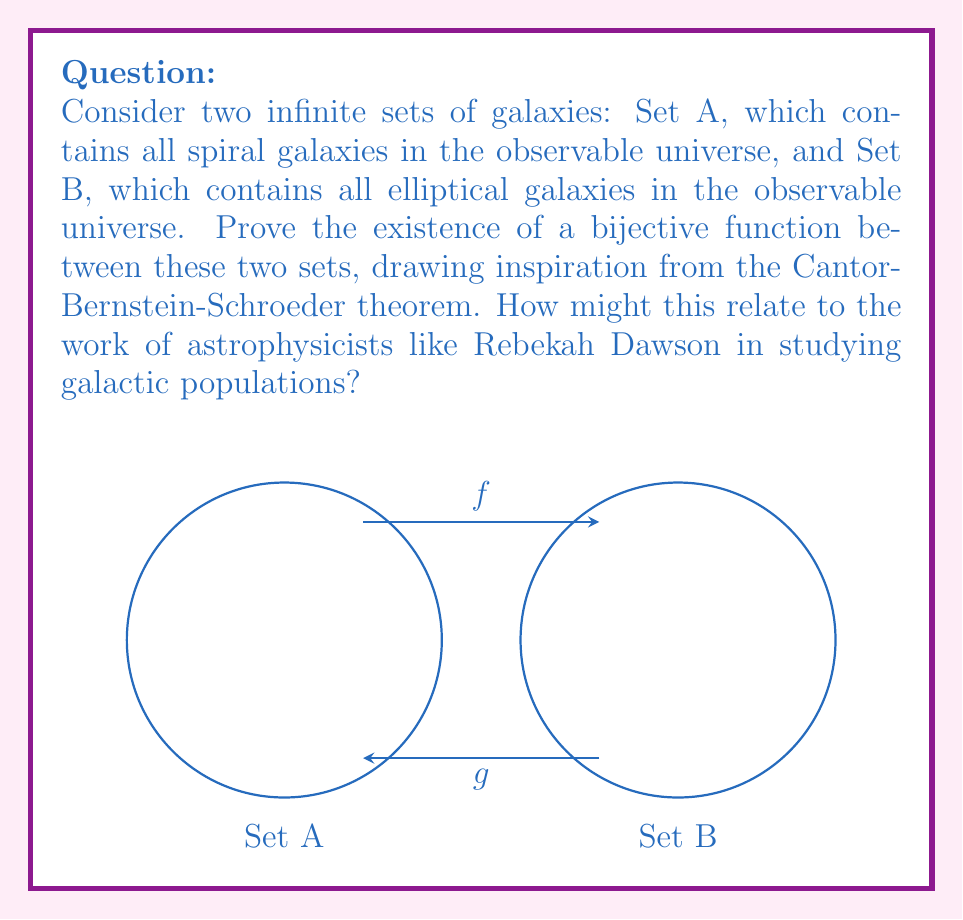Solve this math problem. To prove the existence of a bijective function between Set A (spiral galaxies) and Set B (elliptical galaxies), we can use the Cantor-Bernstein-Schroeder theorem. This theorem states that if there exist injective functions $f: A \to B$ and $g: B \to A$, then there exists a bijective function $h: A \to B$. Let's proceed step-by-step:

1) First, we need to establish that both sets are infinite. This is reasonable given the vast number of galaxies in the observable universe.

2) Next, we need to define injective functions $f$ and $g$:
   
   a) Let $f: A \to B$ be a function that assigns each spiral galaxy in A to a unique elliptical galaxy in B. This could be done, for example, by ordering both sets by their distance from Earth and matching them accordingly.
   
   b) Let $g: B \to A$ be a function that assigns each elliptical galaxy in B to a unique spiral galaxy in A. This could be done similarly, perhaps using a different ordering criterion like galaxy mass.

3) Both $f$ and $g$ are injective because each galaxy in the domain is mapped to a unique galaxy in the codomain.

4) By the Cantor-Bernstein-Schroeder theorem, the existence of these injective functions $f$ and $g$ guarantees the existence of a bijective function $h: A \to B$.

5) The construction of $h$ involves partitioning set A into three disjoint subsets:
   
   $$A = A_0 \cup A_1 \cup A_2$$
   
   Where:
   - $A_0$ contains elements of A not in the range of $g$
   - $A_1$ contains elements of A that are in the range of $g$ and whose pre-images under $g$ are also in the range of $g$
   - $A_2$ contains the remaining elements of A

6) The bijective function $h$ is then defined as:

   $$h(a) = \begin{cases} 
   f(a) & \text{if } a \in A_0 \cup A_1 \\
   g^{-1}(a) & \text{if } a \in A_2
   \end{cases}$$

This proof demonstrates that there exists a one-to-one correspondence between spiral and elliptical galaxies, despite potentially different population sizes or distributions. This relates to astrophysical research, such as that conducted by Rebekah Dawson and colleagues at Harvard, by providing a theoretical framework for comparing different galaxy populations and understanding their relative abundances in the universe.
Answer: A bijective function exists between the sets of spiral and elliptical galaxies by the Cantor-Bernstein-Schroeder theorem. 